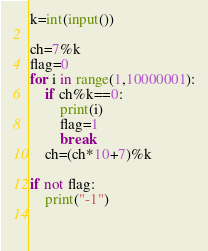Convert code to text. <code><loc_0><loc_0><loc_500><loc_500><_Python_>k=int(input())

ch=7%k
flag=0
for i in range(1,10000001):
    if ch%k==0:
        print(i)
        flag=1
        break
    ch=(ch*10+7)%k
    
if not flag:
    print("-1")

    
</code> 